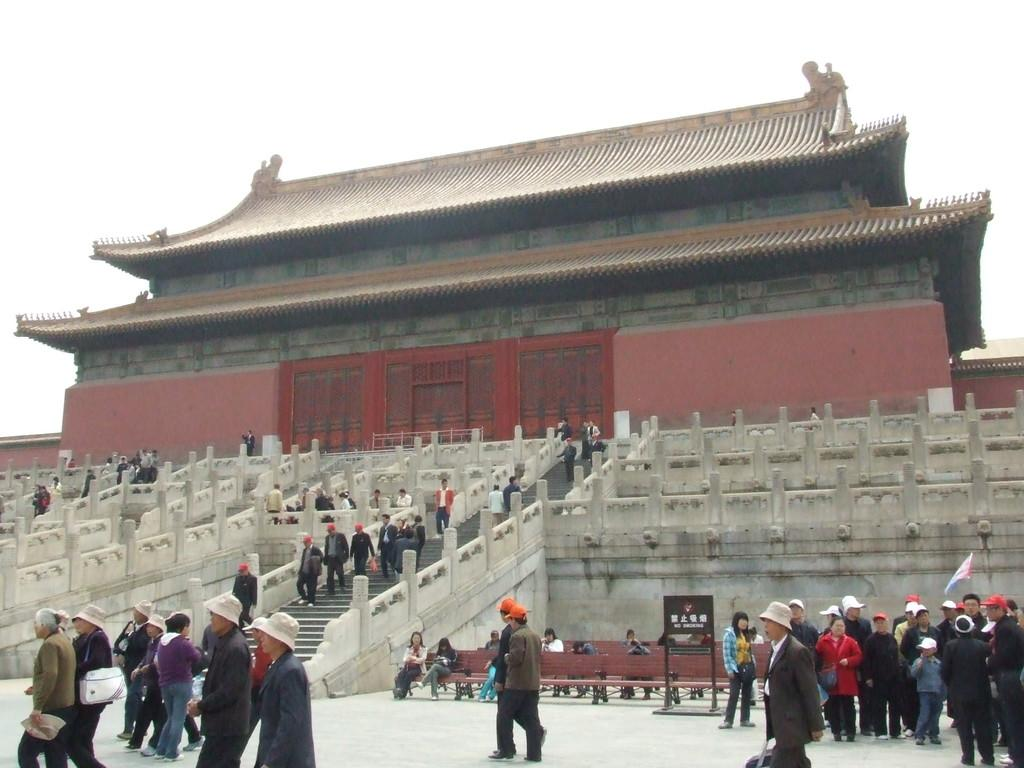What type of structure is visible in the image? There is a building in the image. Are there any architectural features present in the image? Yes, there are stairs in the image. What is the color of the board in the image? The board in the image is brown. What can be seen flying in the image? There is a flag in the image. What type of seating is available in the image? There are benches in the image. What are the people in the image doing? The people in the image are walking. What is the color of the sky in the image? The sky is white in color. How many potatoes are being washed in the sink in the image? There is no sink or potatoes present in the image. How many boys are playing with the flag in the image? There are no boys or flag-playing activity depicted in the image. 